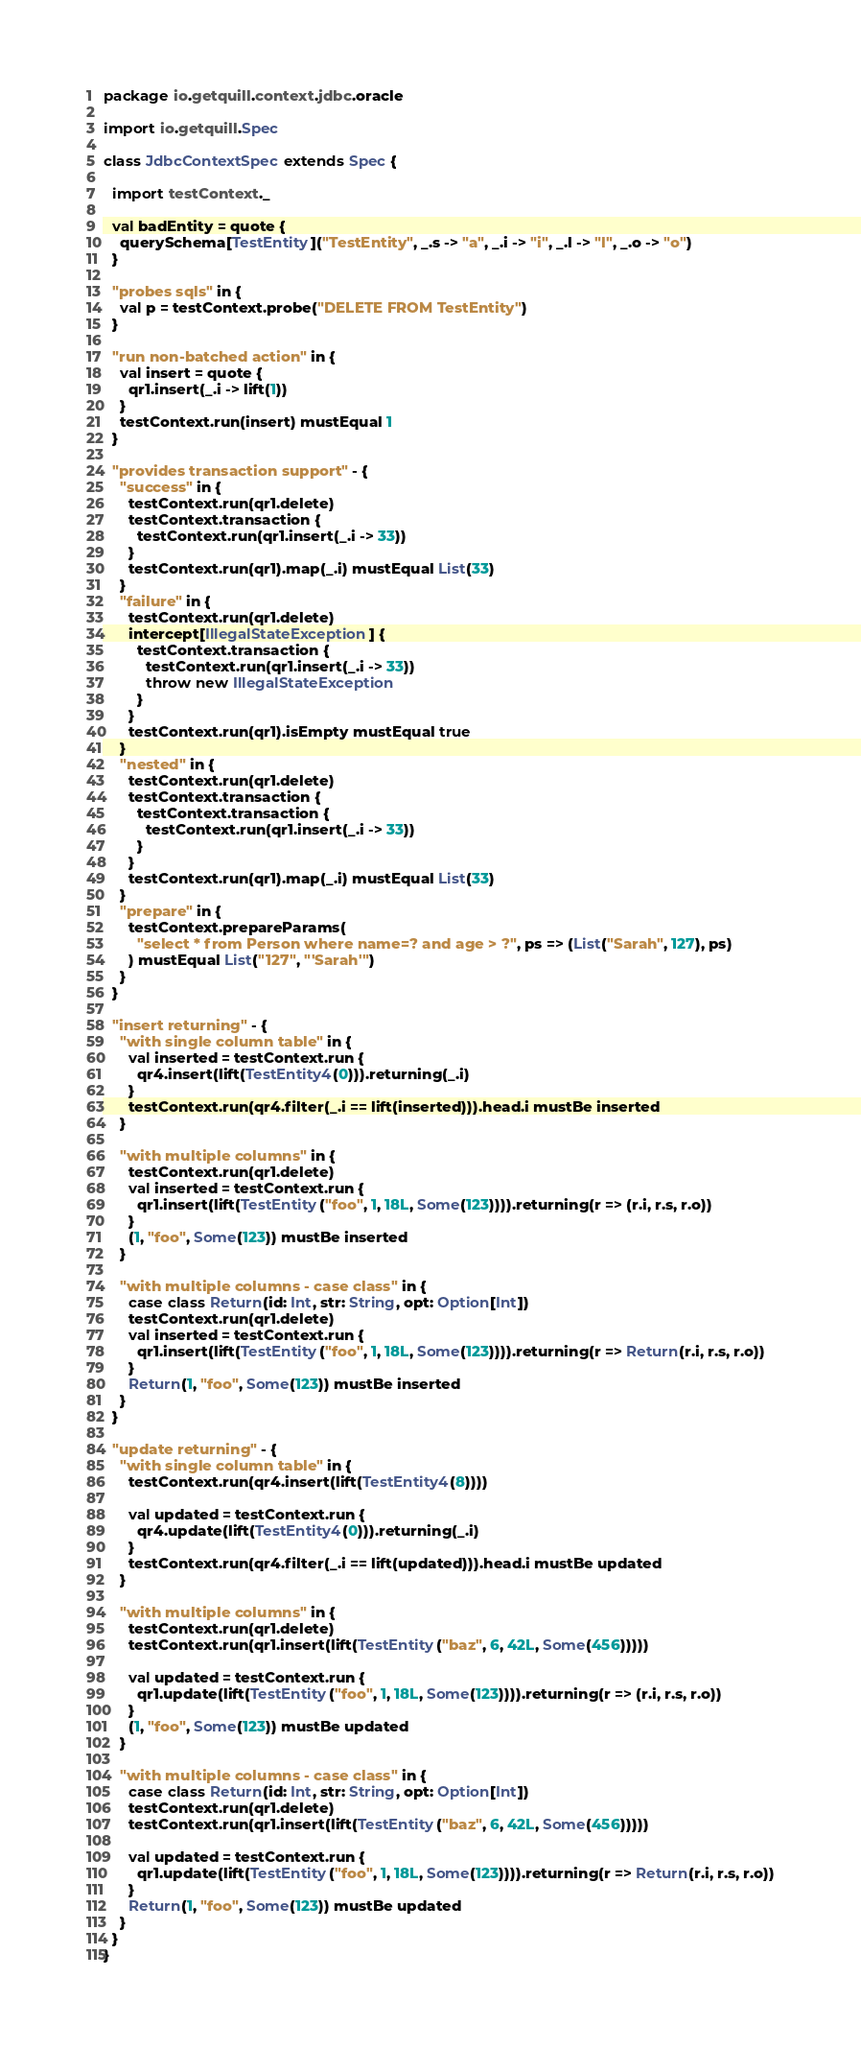Convert code to text. <code><loc_0><loc_0><loc_500><loc_500><_Scala_>package io.getquill.context.jdbc.oracle

import io.getquill.Spec

class JdbcContextSpec extends Spec {

  import testContext._

  val badEntity = quote {
    querySchema[TestEntity]("TestEntity", _.s -> "a", _.i -> "i", _.l -> "l", _.o -> "o")
  }

  "probes sqls" in {
    val p = testContext.probe("DELETE FROM TestEntity")
  }

  "run non-batched action" in {
    val insert = quote {
      qr1.insert(_.i -> lift(1))
    }
    testContext.run(insert) mustEqual 1
  }

  "provides transaction support" - {
    "success" in {
      testContext.run(qr1.delete)
      testContext.transaction {
        testContext.run(qr1.insert(_.i -> 33))
      }
      testContext.run(qr1).map(_.i) mustEqual List(33)
    }
    "failure" in {
      testContext.run(qr1.delete)
      intercept[IllegalStateException] {
        testContext.transaction {
          testContext.run(qr1.insert(_.i -> 33))
          throw new IllegalStateException
        }
      }
      testContext.run(qr1).isEmpty mustEqual true
    }
    "nested" in {
      testContext.run(qr1.delete)
      testContext.transaction {
        testContext.transaction {
          testContext.run(qr1.insert(_.i -> 33))
        }
      }
      testContext.run(qr1).map(_.i) mustEqual List(33)
    }
    "prepare" in {
      testContext.prepareParams(
        "select * from Person where name=? and age > ?", ps => (List("Sarah", 127), ps)
      ) mustEqual List("127", "'Sarah'")
    }
  }

  "insert returning" - {
    "with single column table" in {
      val inserted = testContext.run {
        qr4.insert(lift(TestEntity4(0))).returning(_.i)
      }
      testContext.run(qr4.filter(_.i == lift(inserted))).head.i mustBe inserted
    }

    "with multiple columns" in {
      testContext.run(qr1.delete)
      val inserted = testContext.run {
        qr1.insert(lift(TestEntity("foo", 1, 18L, Some(123)))).returning(r => (r.i, r.s, r.o))
      }
      (1, "foo", Some(123)) mustBe inserted
    }

    "with multiple columns - case class" in {
      case class Return(id: Int, str: String, opt: Option[Int])
      testContext.run(qr1.delete)
      val inserted = testContext.run {
        qr1.insert(lift(TestEntity("foo", 1, 18L, Some(123)))).returning(r => Return(r.i, r.s, r.o))
      }
      Return(1, "foo", Some(123)) mustBe inserted
    }
  }

  "update returning" - {
    "with single column table" in {
      testContext.run(qr4.insert(lift(TestEntity4(8))))

      val updated = testContext.run {
        qr4.update(lift(TestEntity4(0))).returning(_.i)
      }
      testContext.run(qr4.filter(_.i == lift(updated))).head.i mustBe updated
    }

    "with multiple columns" in {
      testContext.run(qr1.delete)
      testContext.run(qr1.insert(lift(TestEntity("baz", 6, 42L, Some(456)))))

      val updated = testContext.run {
        qr1.update(lift(TestEntity("foo", 1, 18L, Some(123)))).returning(r => (r.i, r.s, r.o))
      }
      (1, "foo", Some(123)) mustBe updated
    }

    "with multiple columns - case class" in {
      case class Return(id: Int, str: String, opt: Option[Int])
      testContext.run(qr1.delete)
      testContext.run(qr1.insert(lift(TestEntity("baz", 6, 42L, Some(456)))))

      val updated = testContext.run {
        qr1.update(lift(TestEntity("foo", 1, 18L, Some(123)))).returning(r => Return(r.i, r.s, r.o))
      }
      Return(1, "foo", Some(123)) mustBe updated
    }
  }
}
</code> 